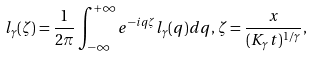<formula> <loc_0><loc_0><loc_500><loc_500>l _ { \gamma } ( \zeta ) = \frac { 1 } { 2 \pi } \int _ { - \infty } ^ { + \infty } e ^ { - i q \zeta } l _ { \gamma } ( q ) d q , \, \zeta = \frac { x } { ( K _ { \gamma } t ) ^ { 1 / \gamma } } ,</formula> 